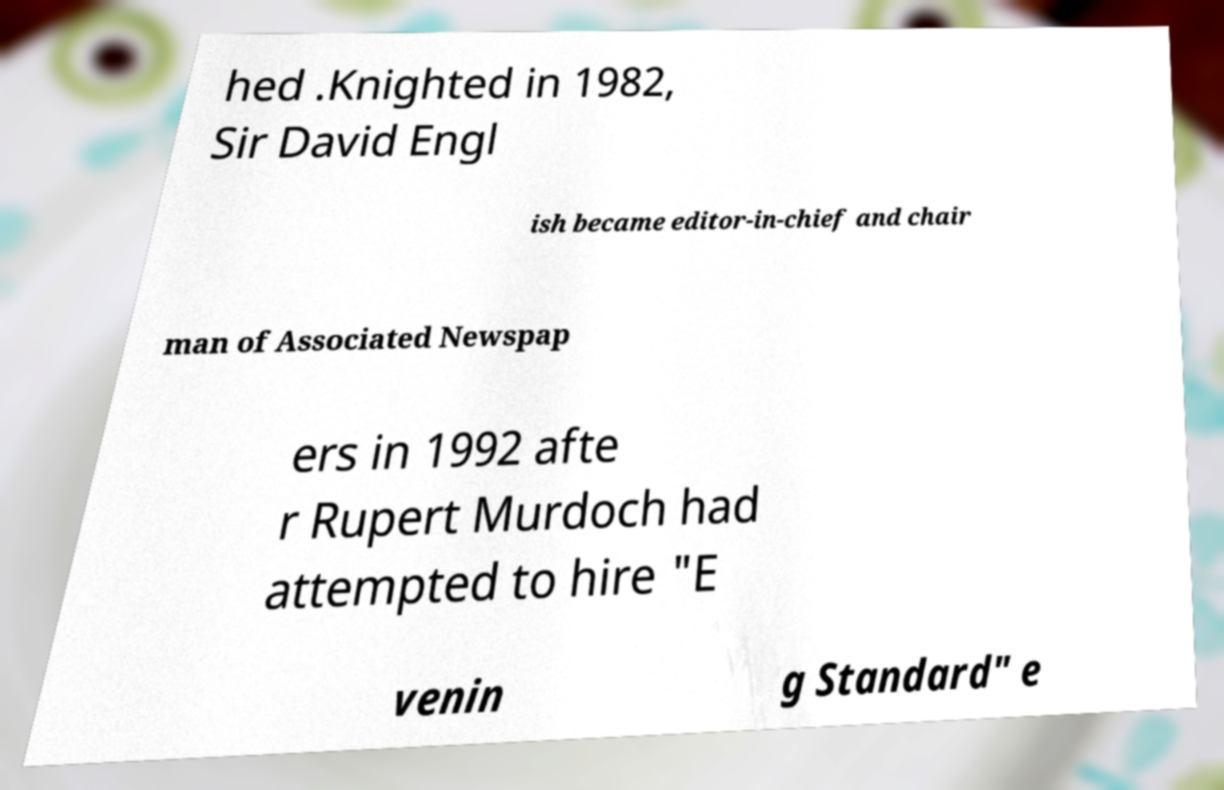Please identify and transcribe the text found in this image. hed .Knighted in 1982, Sir David Engl ish became editor-in-chief and chair man of Associated Newspap ers in 1992 afte r Rupert Murdoch had attempted to hire "E venin g Standard" e 